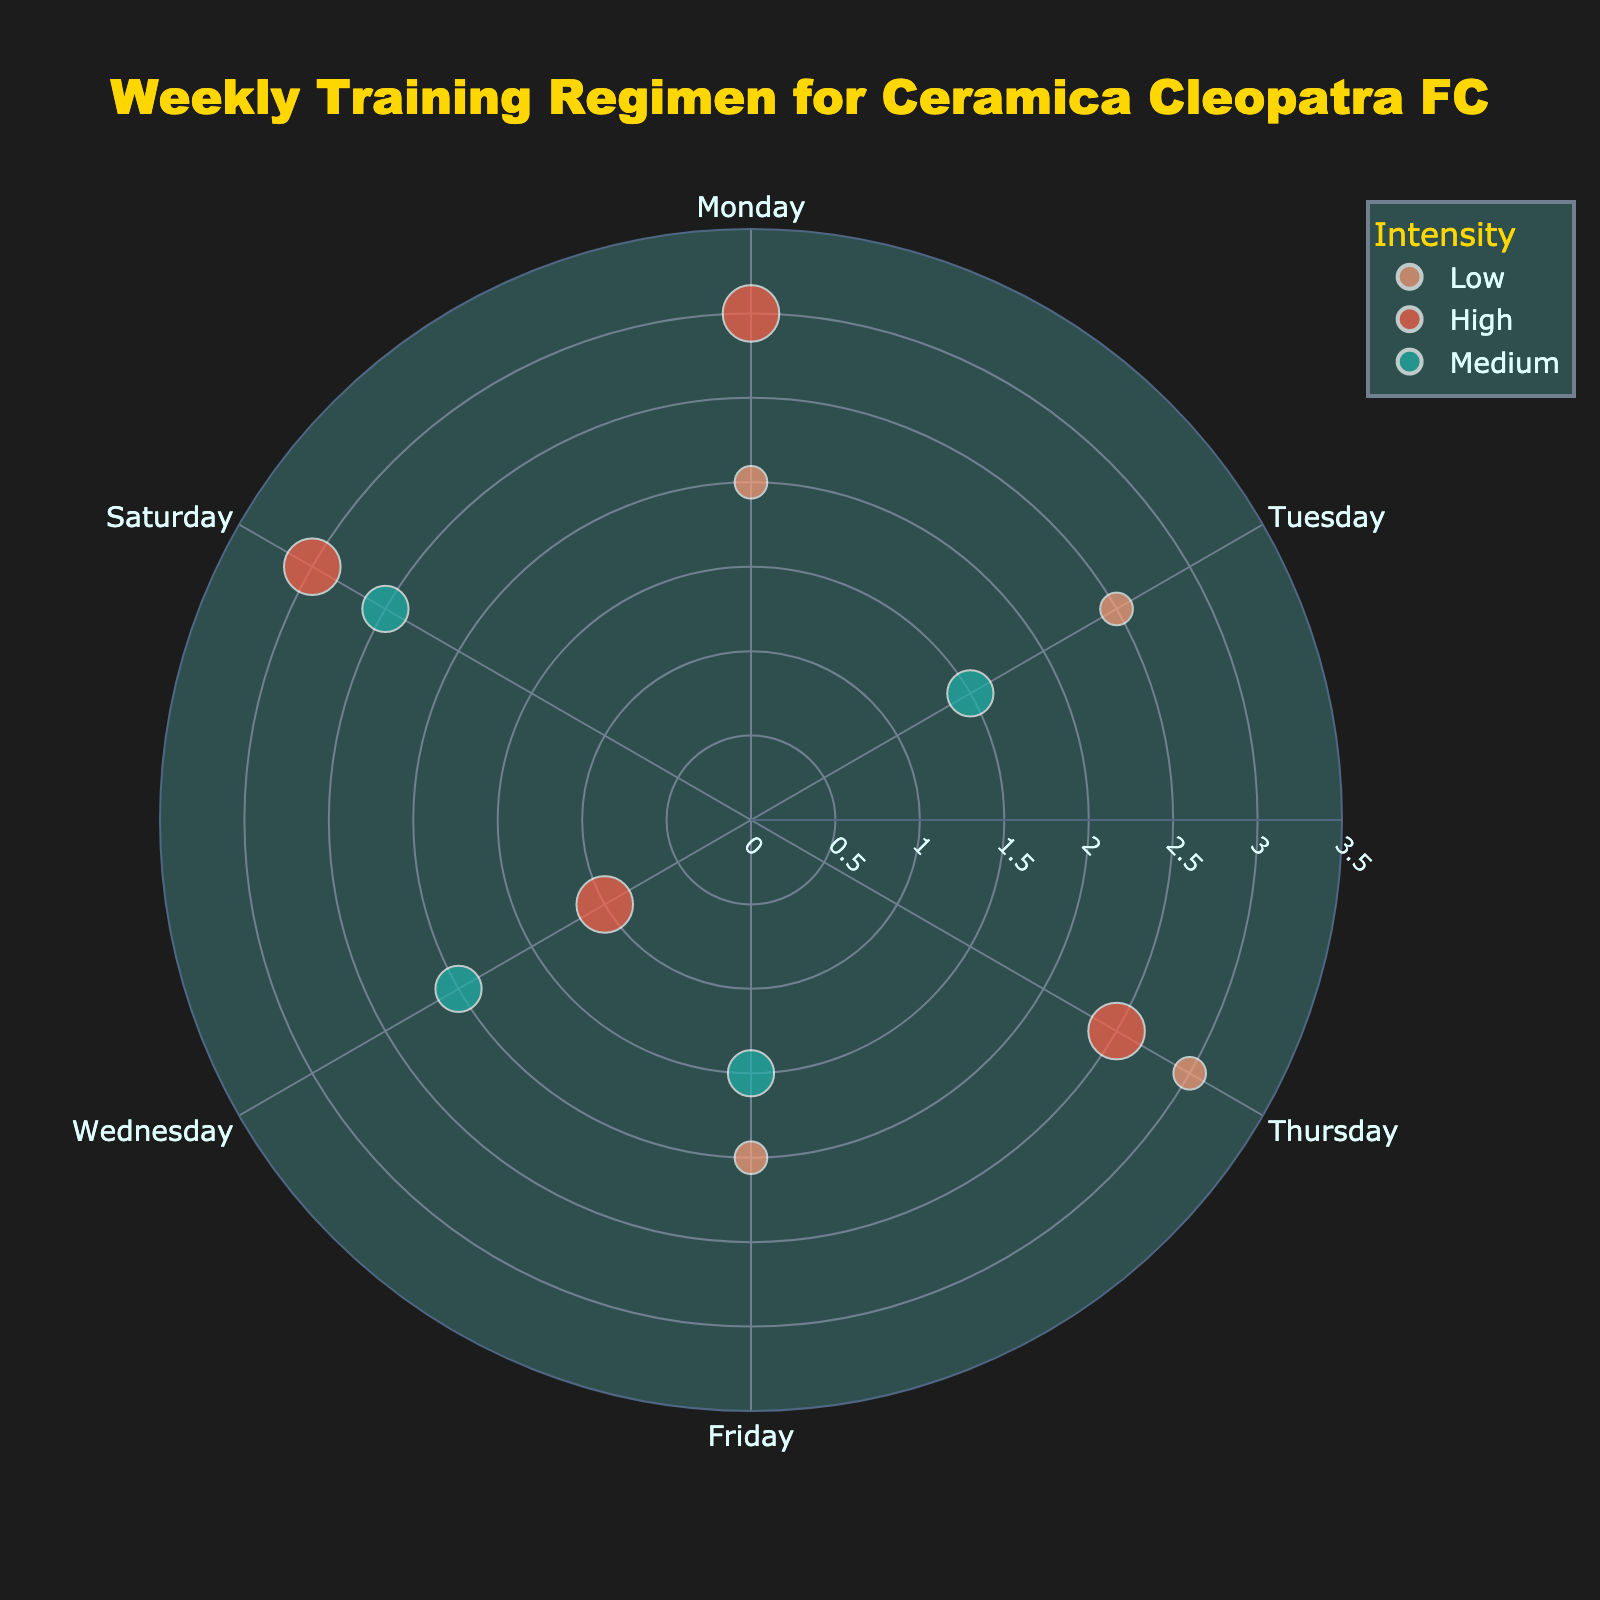What's the title of the chart? Look at the text at the top center of the chart.
Answer: Weekly Training Regimen for Ceramica Cleopatra FC What are the categories of Intensity represented in the chart? Identify the different colors used in the scatter plot legend.
Answer: Low, Medium, High On which day is the highest training duration recorded, and what is the intensity? Look at the radial positions of the bubbles and compare their sizes and colors. The largest bubble represents the highest duration.
Answer: Monday, High What is the duration for 'Medium' intensity training on Saturday? Find the 'Medium' intensity bubble for Saturday by looking for the corresponding color and position. Check the radial axis value at that point.
Answer: 2.5 hours Which day has the lowest amount of 'High' intensity training? Compare the durations (r-values) for all 'High' intensity data points to find the minimum value.
Answer: Wednesday How does the total duration of training on Monday compare with Saturday? Sum the durations of all training intensities on Monday and Saturday and compare the totals.
Answer: Monday: 5 hours, Saturday: 5.5 hours On which day does 'Low' intensity training have the longest duration, and how long is it? Look for the day with the largest 'Low' intensity bubble and read the duration value.
Answer: Thursday, 3 hours How many days include 'Medium' intensity training sessions? Count the number of distinct 'Medium' intensity (color) bubbles across the whole week.
Answer: 5 days What is the average duration of 'High' intensity training sessions throughout the week? Sum all the durations for 'High' intensity training and divide by the number of sessions (use averaging technique).
Answer: (3 + 1 + 2.5 + 3)/4 = 2.375 hours If you sum up the total durations of all 'Low' intensity trainings for the week, what would it be? Add up the radial values corresponding to 'Low' intensity for all days.
Answer: 2 + 2.5 + 3 + 2 = 9.5 hours 